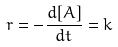Convert formula to latex. <formula><loc_0><loc_0><loc_500><loc_500>r = - \frac { d [ A ] } { d t } = k</formula> 